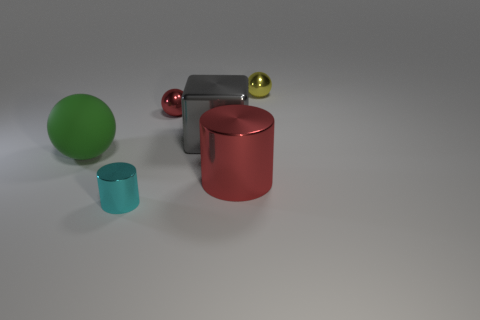Are there fewer small red balls that are in front of the gray metal cube than tiny cyan objects in front of the big red thing?
Your answer should be very brief. Yes. How many other things are the same material as the big green thing?
Your answer should be compact. 0. What material is the green sphere that is the same size as the red cylinder?
Provide a short and direct response. Rubber. Are there fewer green rubber objects in front of the small cyan thing than brown metal blocks?
Your answer should be very brief. No. What shape is the tiny cyan shiny thing to the left of the red metal object that is in front of the big green sphere left of the big shiny cylinder?
Offer a terse response. Cylinder. There is a metallic object in front of the large red thing; how big is it?
Your response must be concise. Small. The other red object that is the same size as the rubber thing is what shape?
Provide a succinct answer. Cylinder. How many objects are either green matte things or big things that are on the left side of the cyan cylinder?
Keep it short and to the point. 1. How many yellow shiny balls are to the left of the tiny object in front of the shiny sphere that is in front of the yellow metal ball?
Provide a succinct answer. 0. The large cylinder that is made of the same material as the red sphere is what color?
Your answer should be very brief. Red. 